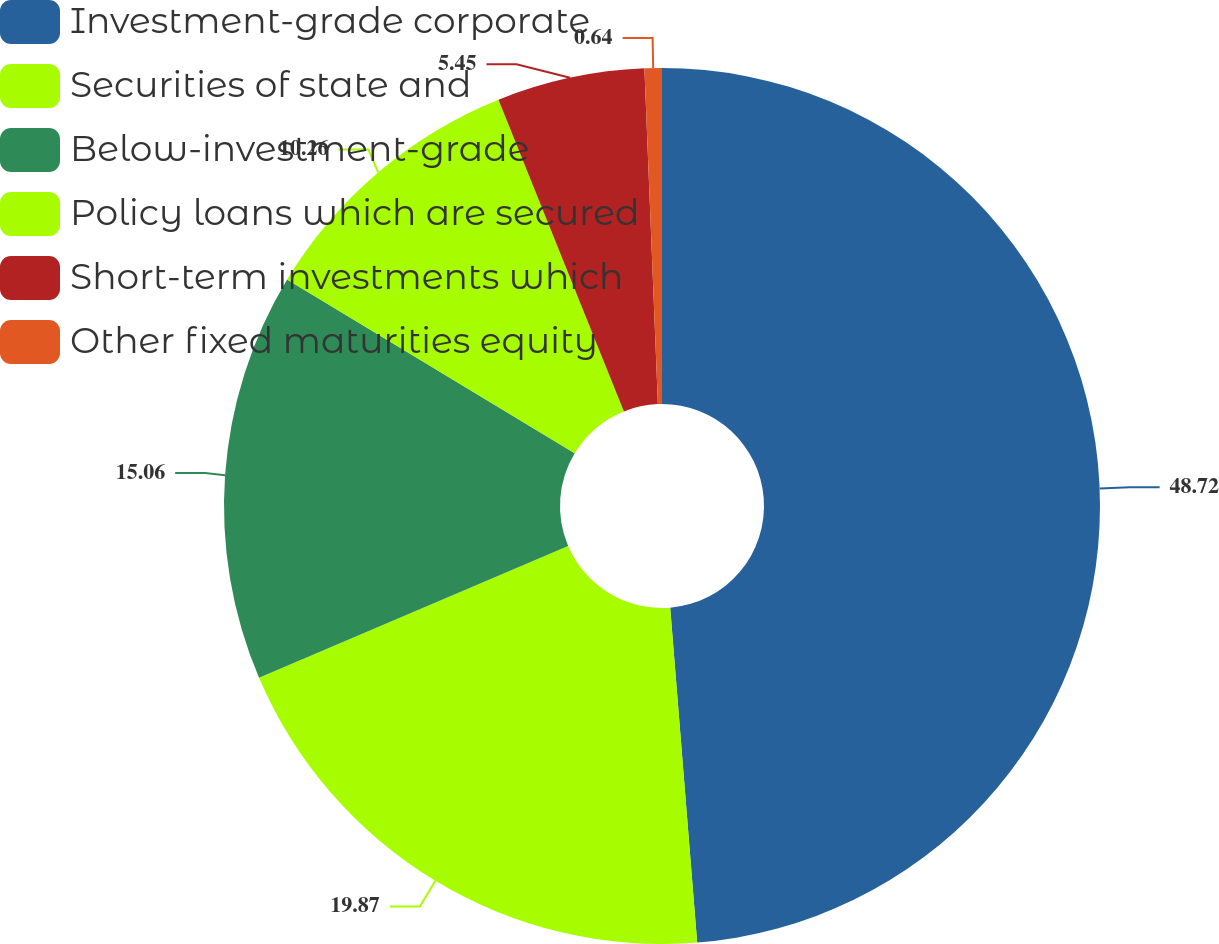<chart> <loc_0><loc_0><loc_500><loc_500><pie_chart><fcel>Investment-grade corporate<fcel>Securities of state and<fcel>Below-investment-grade<fcel>Policy loans which are secured<fcel>Short-term investments which<fcel>Other fixed maturities equity<nl><fcel>48.72%<fcel>19.87%<fcel>15.06%<fcel>10.26%<fcel>5.45%<fcel>0.64%<nl></chart> 